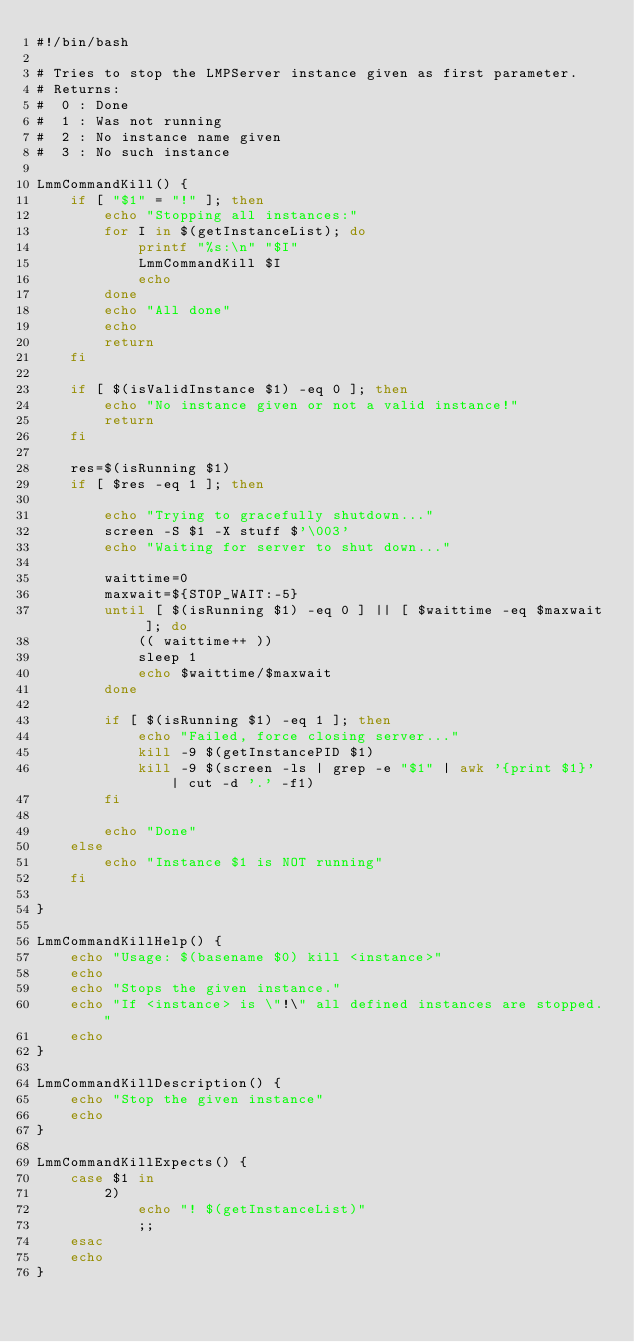<code> <loc_0><loc_0><loc_500><loc_500><_Bash_>#!/bin/bash

# Tries to stop the LMPServer instance given as first parameter.
# Returns:
#  0 : Done
#  1 : Was not running
#  2 : No instance name given
#  3 : No such instance

LmmCommandKill() {
	if [ "$1" = "!" ]; then
		echo "Stopping all instances:"
		for I in $(getInstanceList); do
			printf "%s:\n" "$I"
			LmmCommandKill $I
			echo
		done
		echo "All done"
		echo
		return
	fi

	if [ $(isValidInstance $1) -eq 0 ]; then
		echo "No instance given or not a valid instance!"
		return
	fi

	res=$(isRunning $1)
	if [ $res -eq 1 ]; then

		echo "Trying to gracefully shutdown..."
		screen -S $1 -X stuff $'\003'
		echo "Waiting for server to shut down..."
	
		waittime=0
		maxwait=${STOP_WAIT:-5}
		until [ $(isRunning $1) -eq 0 ] || [ $waittime -eq $maxwait ]; do
			(( waittime++ ))
			sleep 1
			echo $waittime/$maxwait
		done
	
		if [ $(isRunning $1) -eq 1 ]; then
			echo "Failed, force closing server..."
			kill -9 $(getInstancePID $1)
			kill -9 $(screen -ls | grep -e "$1" | awk '{print $1}' | cut -d '.' -f1)
		fi

		echo "Done"	
	else
		echo "Instance $1 is NOT running"
	fi
	
}

LmmCommandKillHelp() {
	echo "Usage: $(basename $0) kill <instance>"
	echo
	echo "Stops the given instance."
	echo "If <instance> is \"!\" all defined instances are stopped."
	echo
}

LmmCommandKillDescription() {
	echo "Stop the given instance"
	echo
}

LmmCommandKillExpects() {
	case $1 in
		2)
			echo "! $(getInstanceList)"
			;;
	esac
	echo
}
</code> 